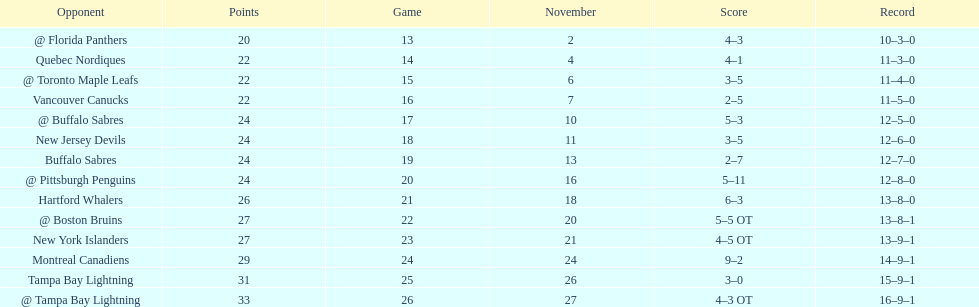What was the number of wins the philadelphia flyers had? 35. 